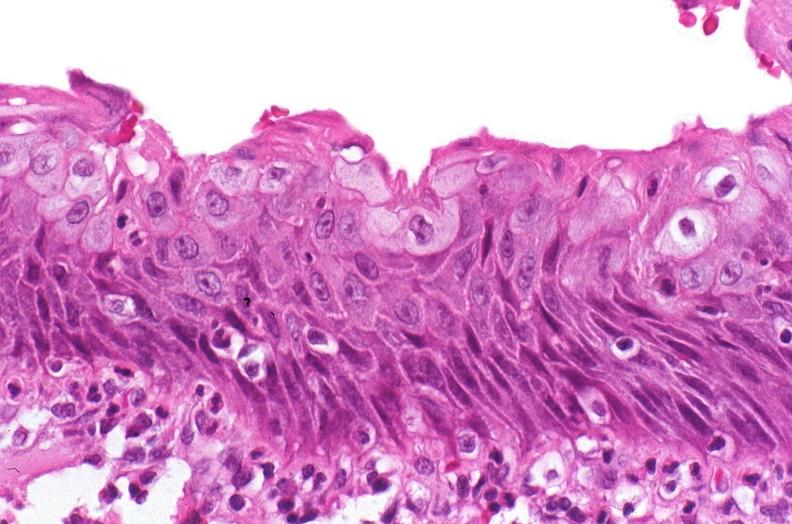where is this?
Answer the question using a single word or phrase. Urinary 